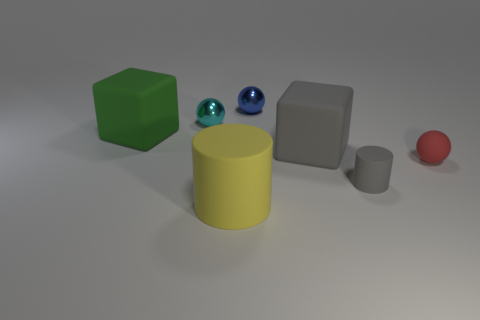How many objects are small blue metallic balls or red spheres?
Make the answer very short. 2. What material is the gray cylinder that is the same size as the blue sphere?
Keep it short and to the point. Rubber. There is a matte cylinder in front of the small gray rubber cylinder; how big is it?
Your answer should be compact. Large. What material is the gray cylinder?
Provide a short and direct response. Rubber. How many things are either spheres behind the large green object or tiny things behind the red object?
Your answer should be compact. 2. How many other objects are the same color as the rubber ball?
Give a very brief answer. 0. There is a red matte object; does it have the same shape as the gray thing that is behind the small matte cylinder?
Provide a short and direct response. No. Is the number of blue things that are on the right side of the large gray thing less than the number of red rubber spheres on the right side of the small cyan shiny ball?
Ensure brevity in your answer.  Yes. There is a small red object that is the same shape as the blue object; what is it made of?
Provide a succinct answer. Rubber. There is a big gray object that is the same material as the red object; what is its shape?
Provide a succinct answer. Cube. 